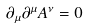<formula> <loc_0><loc_0><loc_500><loc_500>\partial _ { \mu } \partial ^ { \mu } A ^ { \nu } = 0</formula> 